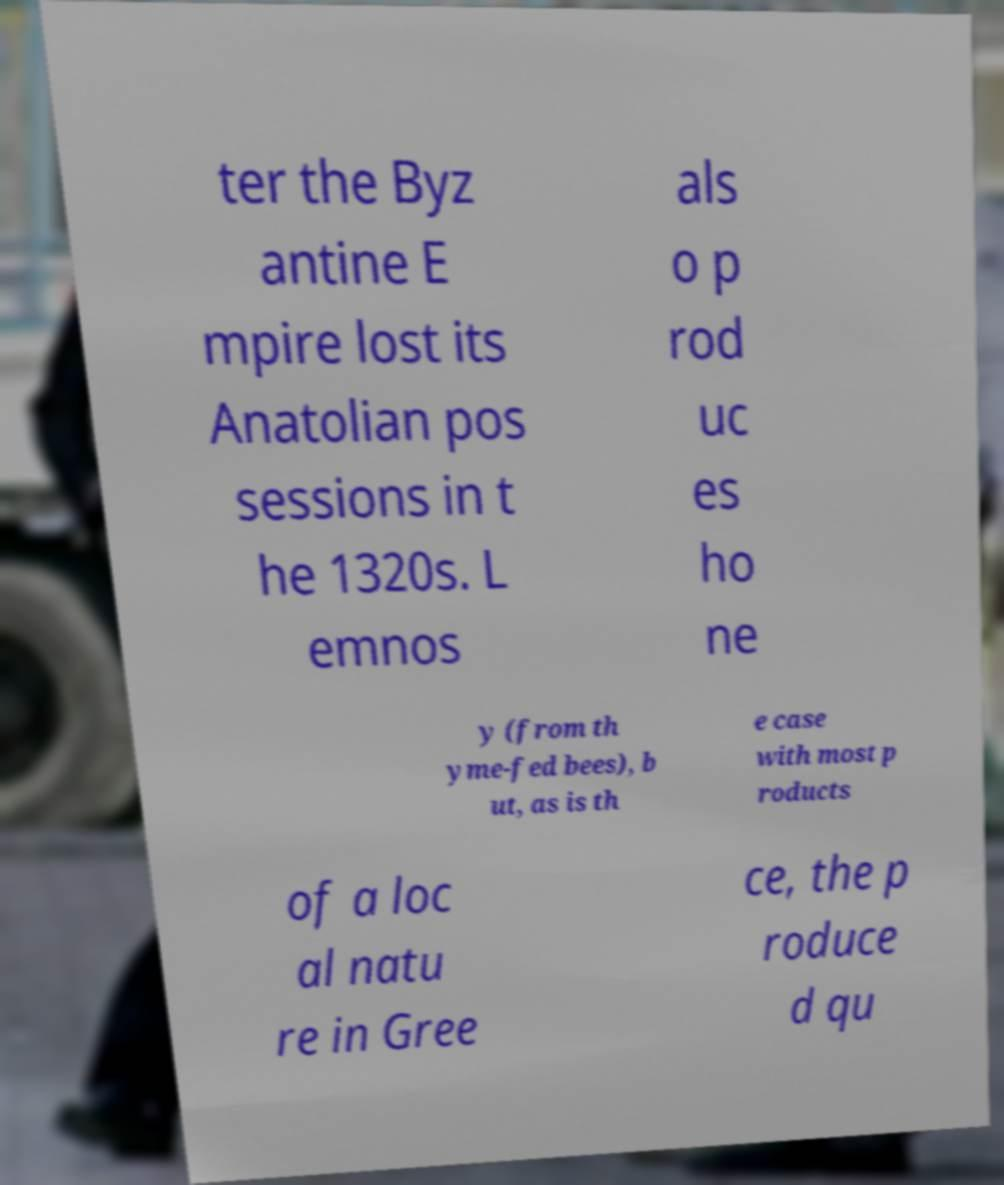Could you assist in decoding the text presented in this image and type it out clearly? ter the Byz antine E mpire lost its Anatolian pos sessions in t he 1320s. L emnos als o p rod uc es ho ne y (from th yme-fed bees), b ut, as is th e case with most p roducts of a loc al natu re in Gree ce, the p roduce d qu 